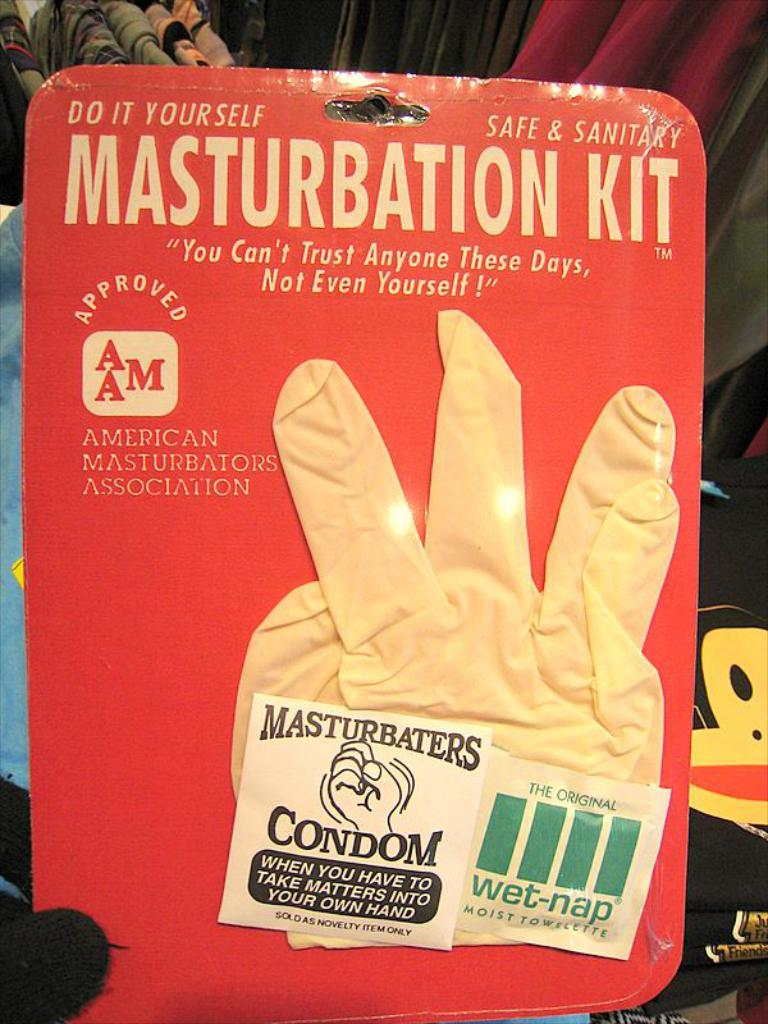<image>
Relay a brief, clear account of the picture shown. A kit that markets itself as a do it yourself masturbation kit 